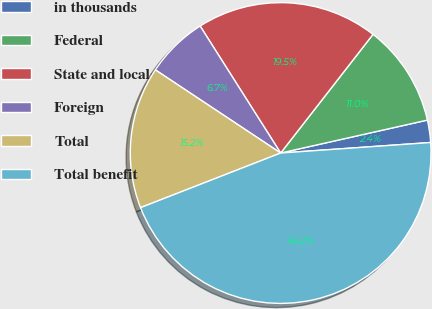<chart> <loc_0><loc_0><loc_500><loc_500><pie_chart><fcel>in thousands<fcel>Federal<fcel>State and local<fcel>Foreign<fcel>Total<fcel>Total benefit<nl><fcel>2.4%<fcel>10.96%<fcel>19.52%<fcel>6.68%<fcel>15.24%<fcel>45.2%<nl></chart> 